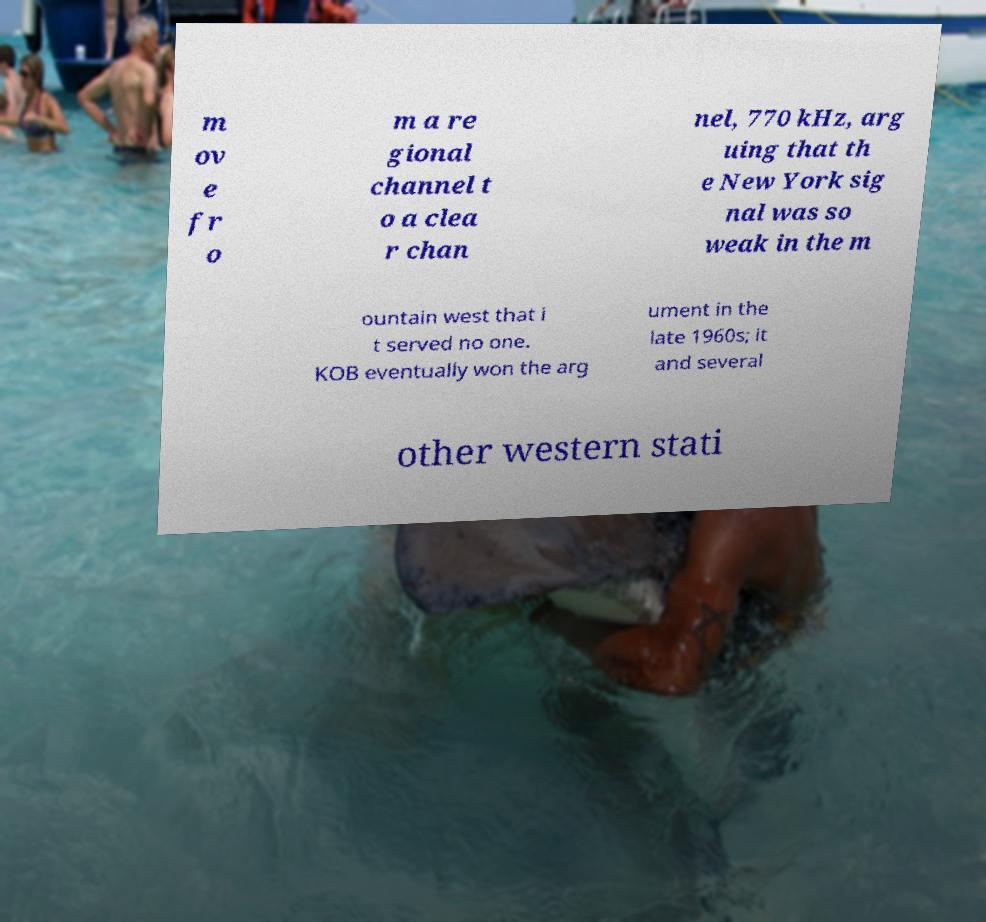Could you extract and type out the text from this image? m ov e fr o m a re gional channel t o a clea r chan nel, 770 kHz, arg uing that th e New York sig nal was so weak in the m ountain west that i t served no one. KOB eventually won the arg ument in the late 1960s; it and several other western stati 